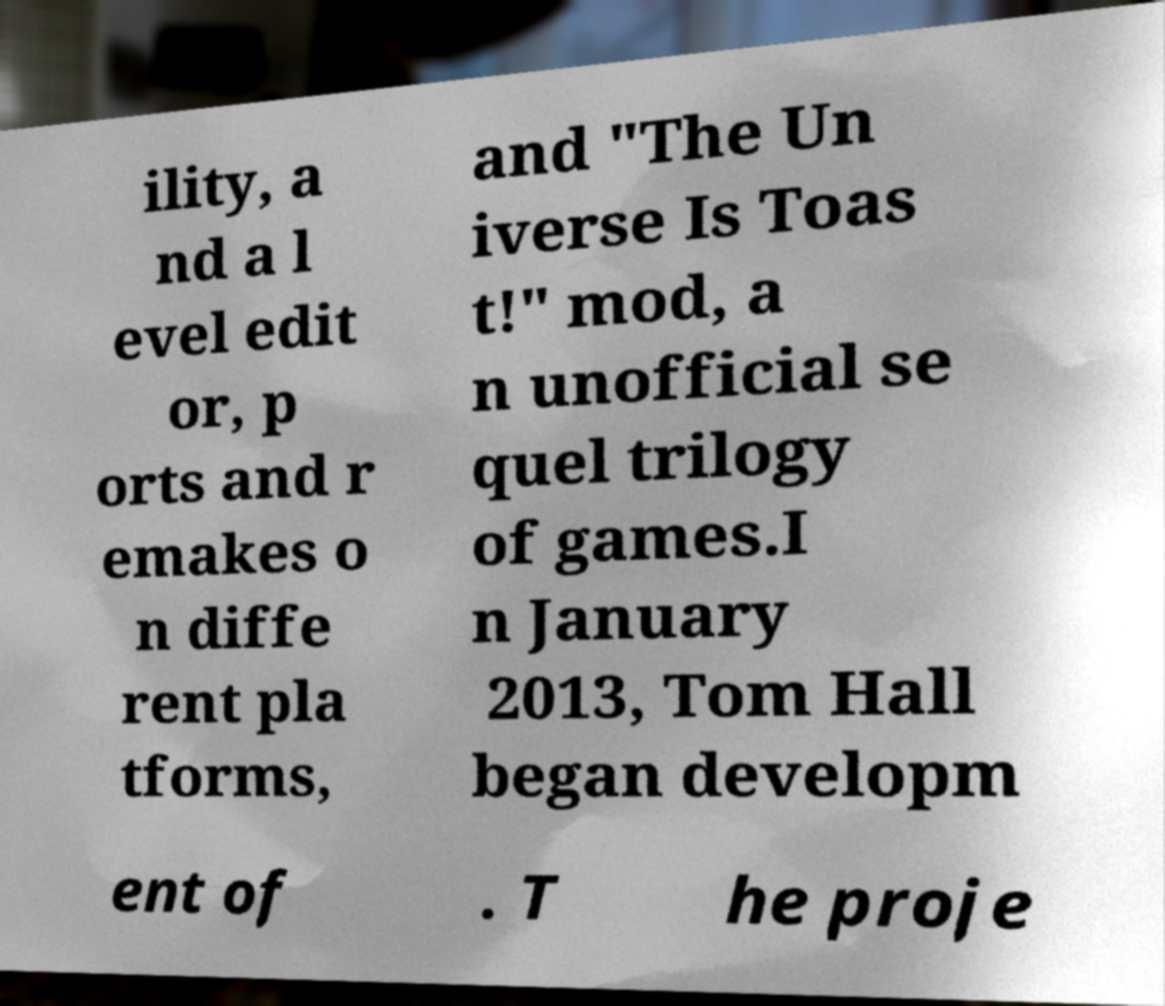Could you extract and type out the text from this image? ility, a nd a l evel edit or, p orts and r emakes o n diffe rent pla tforms, and "The Un iverse Is Toas t!" mod, a n unofficial se quel trilogy of games.I n January 2013, Tom Hall began developm ent of . T he proje 